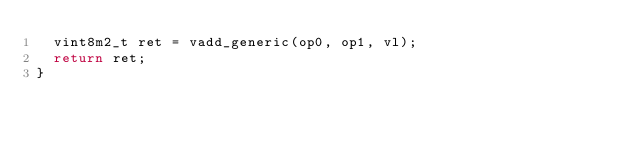Convert code to text. <code><loc_0><loc_0><loc_500><loc_500><_C_>  vint8m2_t ret = vadd_generic(op0, op1, vl);
  return ret;
}
</code> 